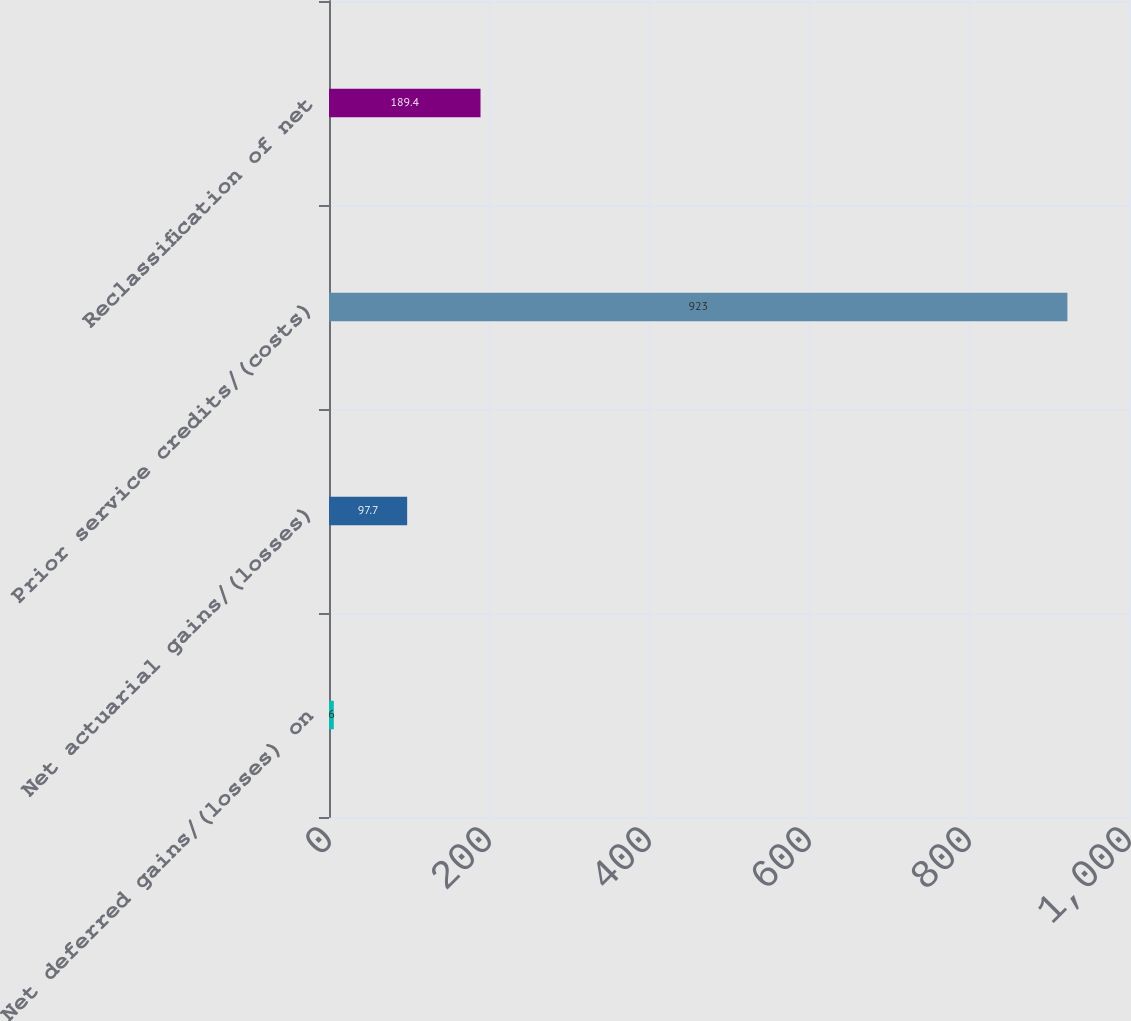Convert chart. <chart><loc_0><loc_0><loc_500><loc_500><bar_chart><fcel>Net deferred gains/(losses) on<fcel>Net actuarial gains/(losses)<fcel>Prior service credits/(costs)<fcel>Reclassification of net<nl><fcel>6<fcel>97.7<fcel>923<fcel>189.4<nl></chart> 